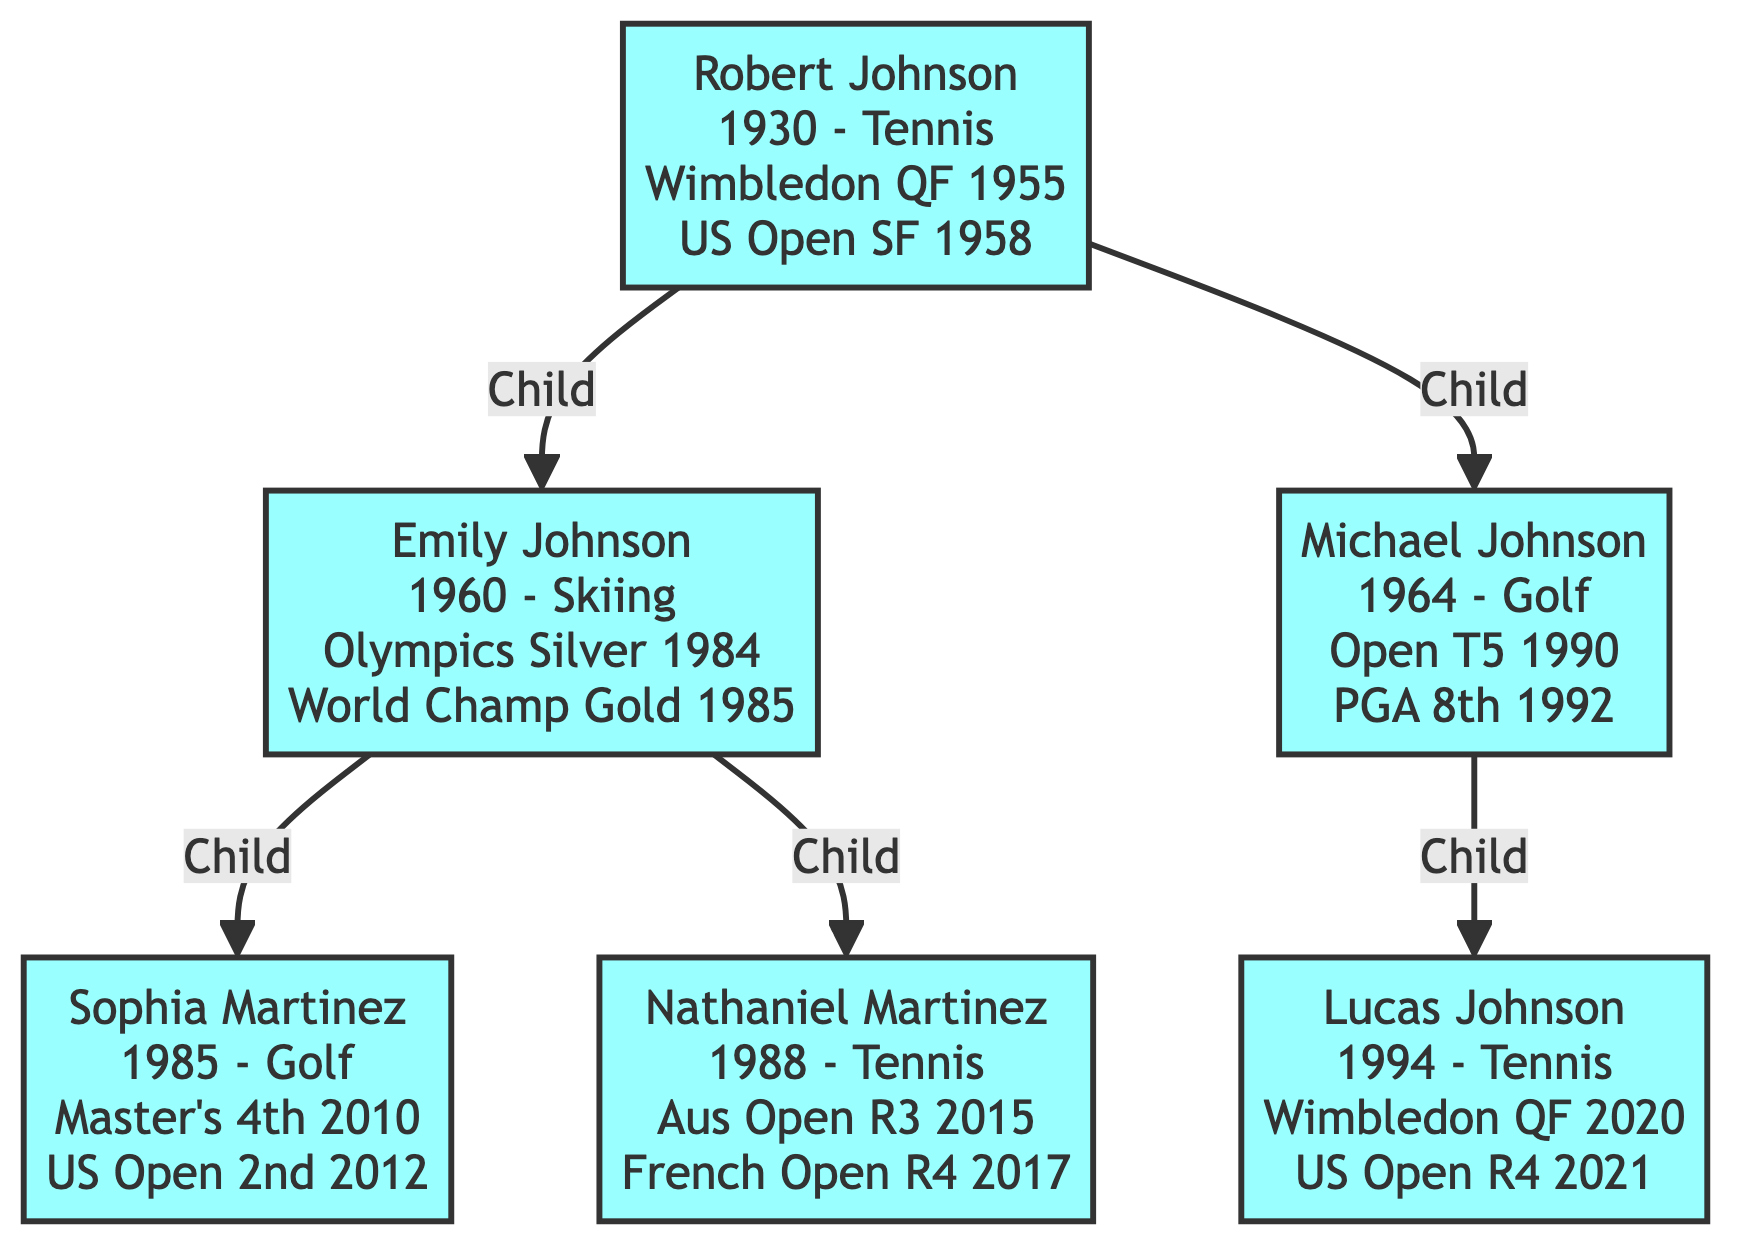What sport did Robert Johnson compete in? Robert Johnson is linked directly to the "Progenitor" node in the diagram, which indicates that his sport is Tennis.
Answer: Tennis In what year did Emily Johnson win a gold medal? Looking at Emily Johnson's achievements, the diagram shows she won a gold medal in the FIS Alpine World Ski Championships in 1985.
Answer: 1985 How many children did Robert Johnson have? The diagram displays Robert Johnson having two children: Emily and Michael Johnson, indicated by two arrows pointing to them.
Answer: 2 Which competition did Nathaniel Martinez reach the Fourth Round in? The diagram outlines Nathaniel Martinez’s achievements, specifying that he reached the Fourth Round in the French Open in 2017.
Answer: French Open What is the placement of Sophia Martinez in the US Women's Open? Reviewing the achievements of Sophia Martinez, the diagram reveals she placed 2nd in the US Women's Open in 2012.
Answer: 2nd Which descendant of Emily competed in Tennis? The diagram shows two descendants of Emily Johnson, Nathaniel Martinez and Sophia Martinez. Nathaniel Martinez's node specifies he competes in Tennis.
Answer: Nathaniel Martinez Who participated in both Tennis and Golf in this family tree? The diagram indicates that Robert Johnson competed in Tennis, Emily Johnson in Skiing, Michael Johnson in Golf, while Nathaniel and Lucas Martinez participated in Tennis, making Michael Johnson the one who participated in both Tennis and Golf.
Answer: Michael Johnson Which medal did Emily Johnson win at the Winter Olympics? In the diagram, Emily Johnson’s achievements include a Silver medal at the Winter Olympics in 1984, clearly showing her accolade.
Answer: Silver How many total generations are shown in the family tree? The diagram presents three generations: the Progenitor Robert Johnson, his children Emily and Michael, and their respective children.
Answer: 3 